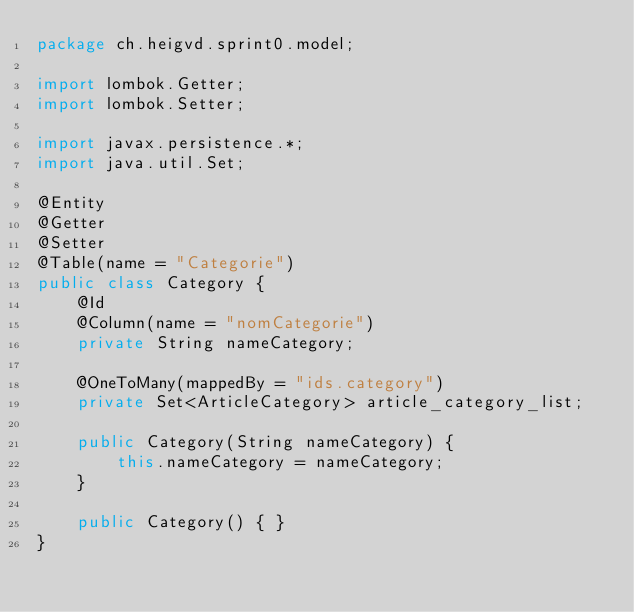Convert code to text. <code><loc_0><loc_0><loc_500><loc_500><_Java_>package ch.heigvd.sprint0.model;

import lombok.Getter;
import lombok.Setter;

import javax.persistence.*;
import java.util.Set;

@Entity
@Getter
@Setter
@Table(name = "Categorie")
public class Category {
    @Id
    @Column(name = "nomCategorie")
    private String nameCategory;

    @OneToMany(mappedBy = "ids.category")
    private Set<ArticleCategory> article_category_list;

    public Category(String nameCategory) {
        this.nameCategory = nameCategory;
    }

    public Category() { }
}
</code> 